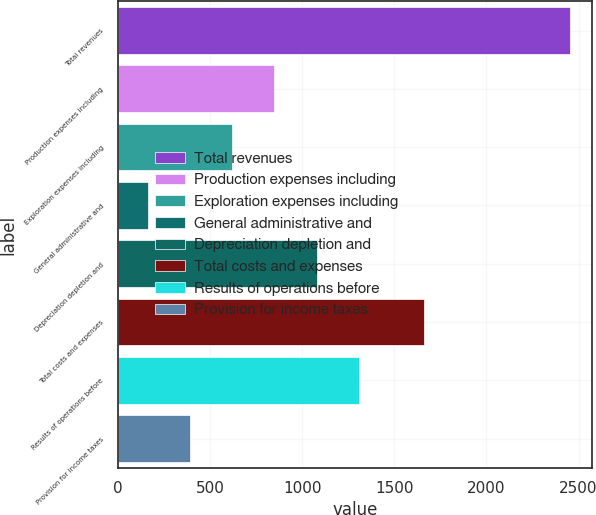Convert chart to OTSL. <chart><loc_0><loc_0><loc_500><loc_500><bar_chart><fcel>Total revenues<fcel>Production expenses including<fcel>Exploration expenses including<fcel>General administrative and<fcel>Depreciation depletion and<fcel>Total costs and expenses<fcel>Results of operations before<fcel>Provision for income taxes<nl><fcel>2453<fcel>848.6<fcel>619.4<fcel>161<fcel>1077.8<fcel>1663<fcel>1307<fcel>390.2<nl></chart> 